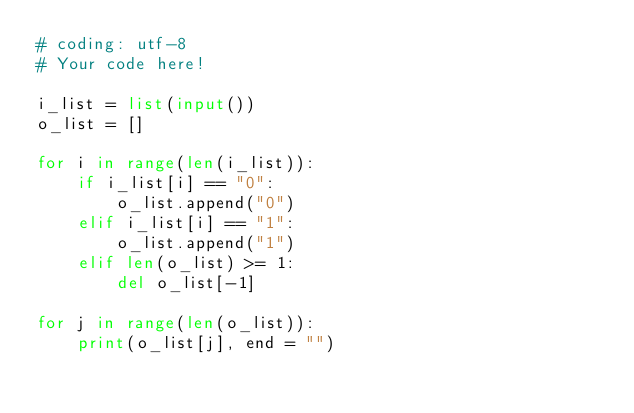<code> <loc_0><loc_0><loc_500><loc_500><_Python_># coding: utf-8
# Your code here!

i_list = list(input())
o_list = []

for i in range(len(i_list)):
    if i_list[i] == "0":
        o_list.append("0")
    elif i_list[i] == "1":
        o_list.append("1")
    elif len(o_list) >= 1:
        del o_list[-1]

for j in range(len(o_list)):
    print(o_list[j], end = "")
</code> 